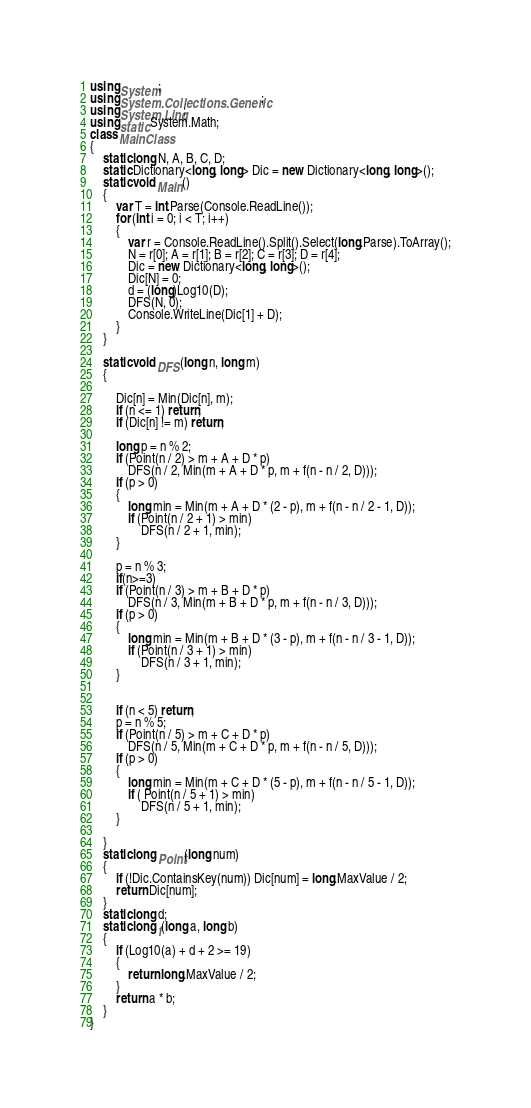<code> <loc_0><loc_0><loc_500><loc_500><_C#_>using System;
using System.Collections.Generic;
using System.Linq;
using static System.Math;
class MainClass
{
    static long N, A, B, C, D;
    static Dictionary<long, long> Dic = new Dictionary<long, long>();
    static void Main()
    {
        var T = int.Parse(Console.ReadLine());
        for (int i = 0; i < T; i++)
        {
            var r = Console.ReadLine().Split().Select(long.Parse).ToArray();
            N = r[0]; A = r[1]; B = r[2]; C = r[3]; D = r[4];
            Dic = new Dictionary<long, long>();
            Dic[N] = 0;
            d = (long)Log10(D);
            DFS(N, 0);
            Console.WriteLine(Dic[1] + D);
        }
    }

    static void DFS(long n, long m)
    {

        Dic[n] = Min(Dic[n], m);
        if (n <= 1) return;
        if (Dic[n] != m) return;

        long p = n % 2;
        if (Point(n / 2) > m + A + D * p)
            DFS(n / 2, Min(m + A + D * p, m + f(n - n / 2, D)));
        if (p > 0)
        {
            long min = Min(m + A + D * (2 - p), m + f(n - n / 2 - 1, D));
            if (Point(n / 2 + 1) > min)
                DFS(n / 2 + 1, min);
        }

        p = n % 3;
        if(n>=3)
        if (Point(n / 3) > m + B + D * p)
            DFS(n / 3, Min(m + B + D * p, m + f(n - n / 3, D)));
        if (p > 0)
        {
            long min = Min(m + B + D * (3 - p), m + f(n - n / 3 - 1, D));
            if (Point(n / 3 + 1) > min)
                DFS(n / 3 + 1, min);
        }


        if (n < 5) return;
        p = n % 5;
        if (Point(n / 5) > m + C + D * p)
            DFS(n / 5, Min(m + C + D * p, m + f(n - n / 5, D)));
        if (p > 0)
        {
            long min = Min(m + C + D * (5 - p), m + f(n - n / 5 - 1, D));
            if ( Point(n / 5 + 1) > min)
                DFS(n / 5 + 1, min);
        }

    }
    static long Point(long num)
    {
        if (!Dic.ContainsKey(num)) Dic[num] = long.MaxValue / 2;
        return Dic[num];
    }
    static long d;
    static long f(long a, long b)
    {
        if (Log10(a) + d + 2 >= 19)
        {
            return long.MaxValue / 2;
        }
        return a * b;
    }
}
</code> 